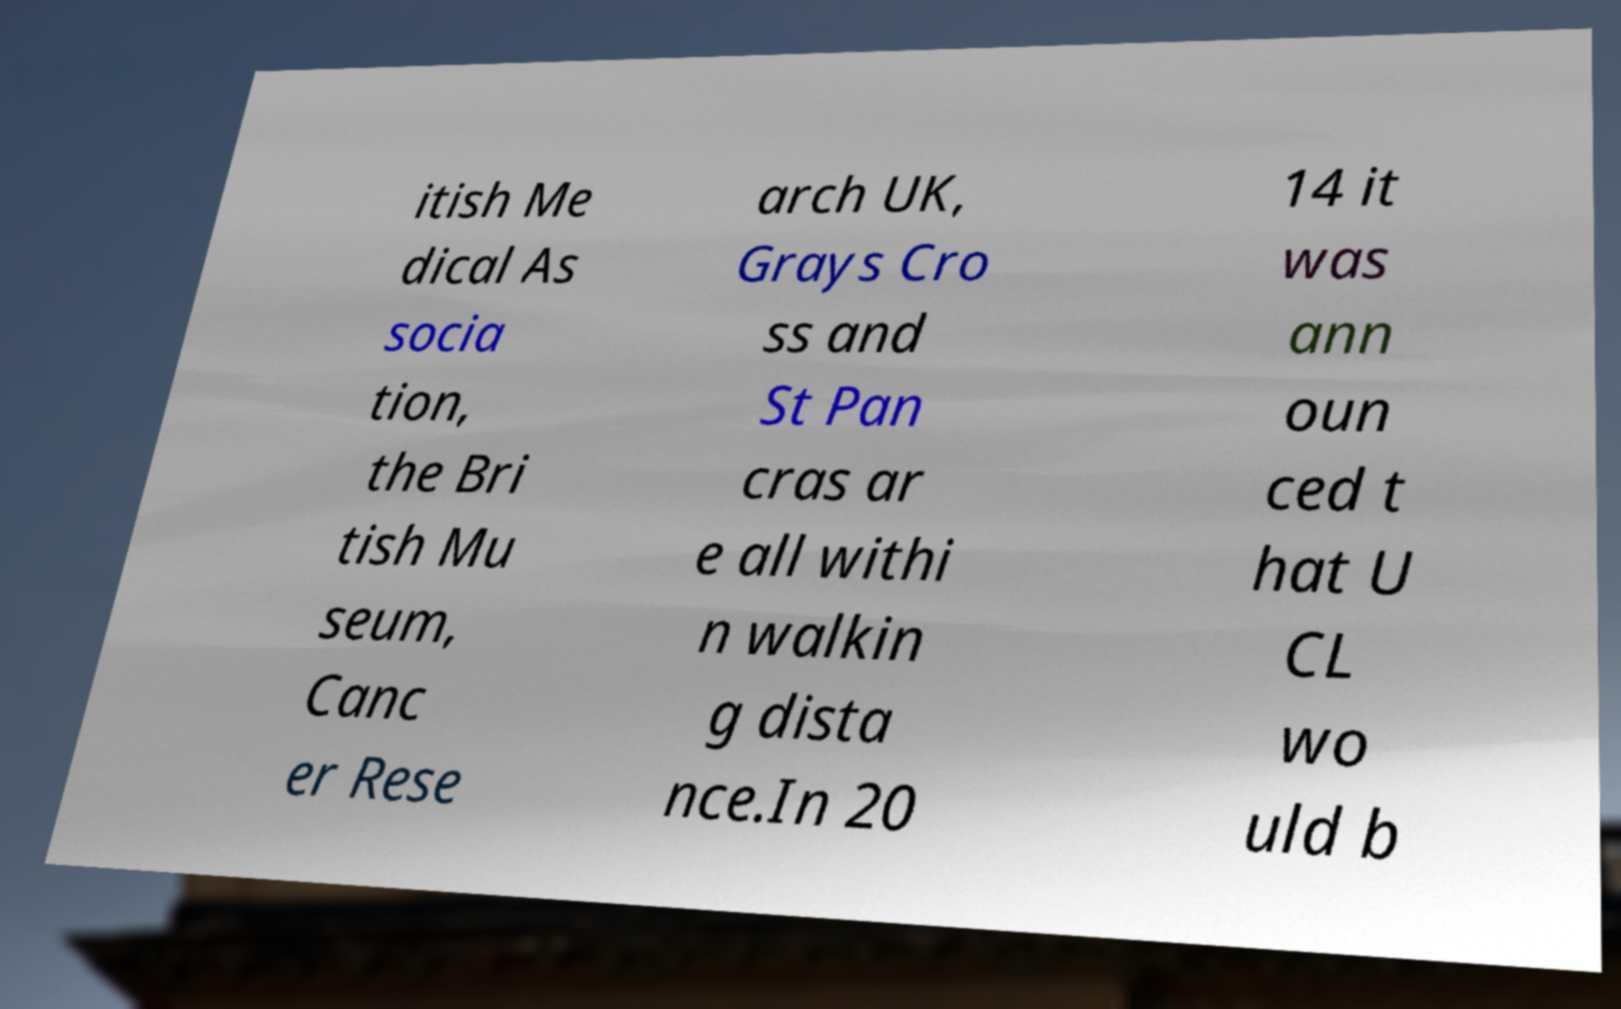Could you assist in decoding the text presented in this image and type it out clearly? itish Me dical As socia tion, the Bri tish Mu seum, Canc er Rese arch UK, Grays Cro ss and St Pan cras ar e all withi n walkin g dista nce.In 20 14 it was ann oun ced t hat U CL wo uld b 